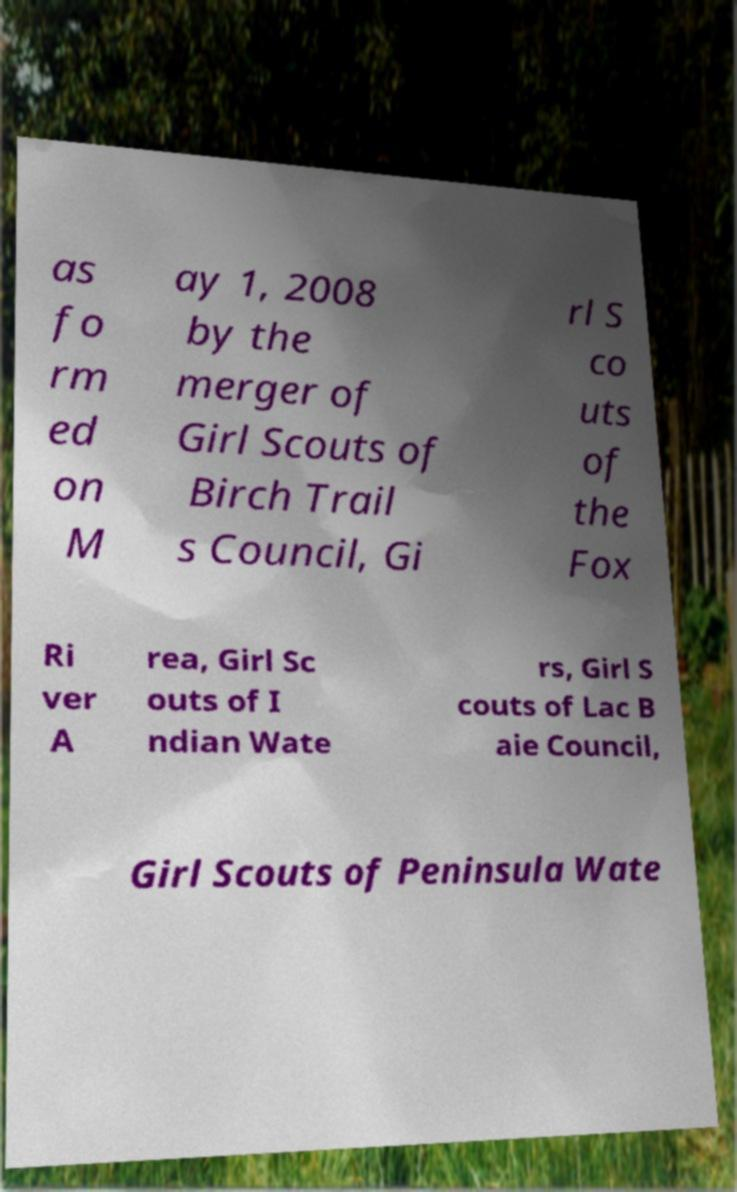There's text embedded in this image that I need extracted. Can you transcribe it verbatim? as fo rm ed on M ay 1, 2008 by the merger of Girl Scouts of Birch Trail s Council, Gi rl S co uts of the Fox Ri ver A rea, Girl Sc outs of I ndian Wate rs, Girl S couts of Lac B aie Council, Girl Scouts of Peninsula Wate 